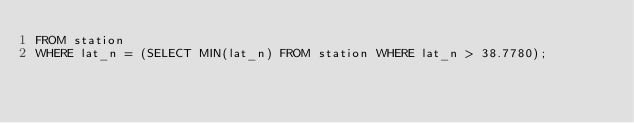<code> <loc_0><loc_0><loc_500><loc_500><_SQL_>FROM station
WHERE lat_n = (SELECT MIN(lat_n) FROM station WHERE lat_n > 38.7780);</code> 